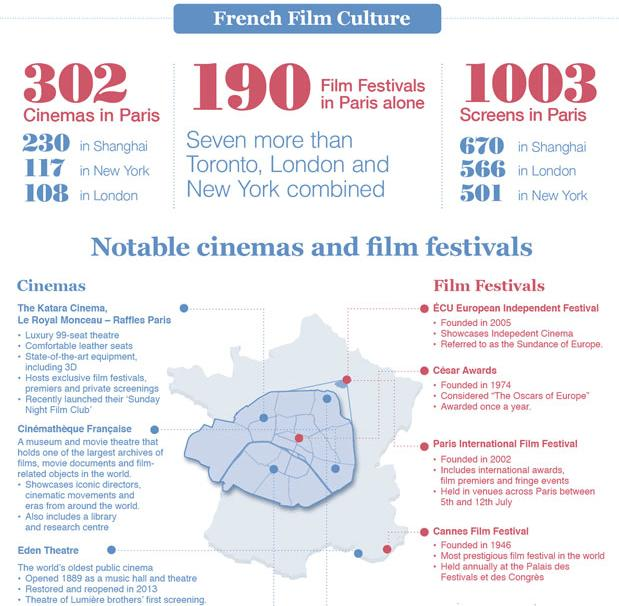List a handful of essential elements in this visual. ECU European Independent Film Festival is the most recent film festival among the listed ones, having been founded recently. The Cannes Film Festival, founded before 1950, is a film festival that is well-known and highly respected in the film industry. Shanghai has the highest number of cinemas after Paris. 